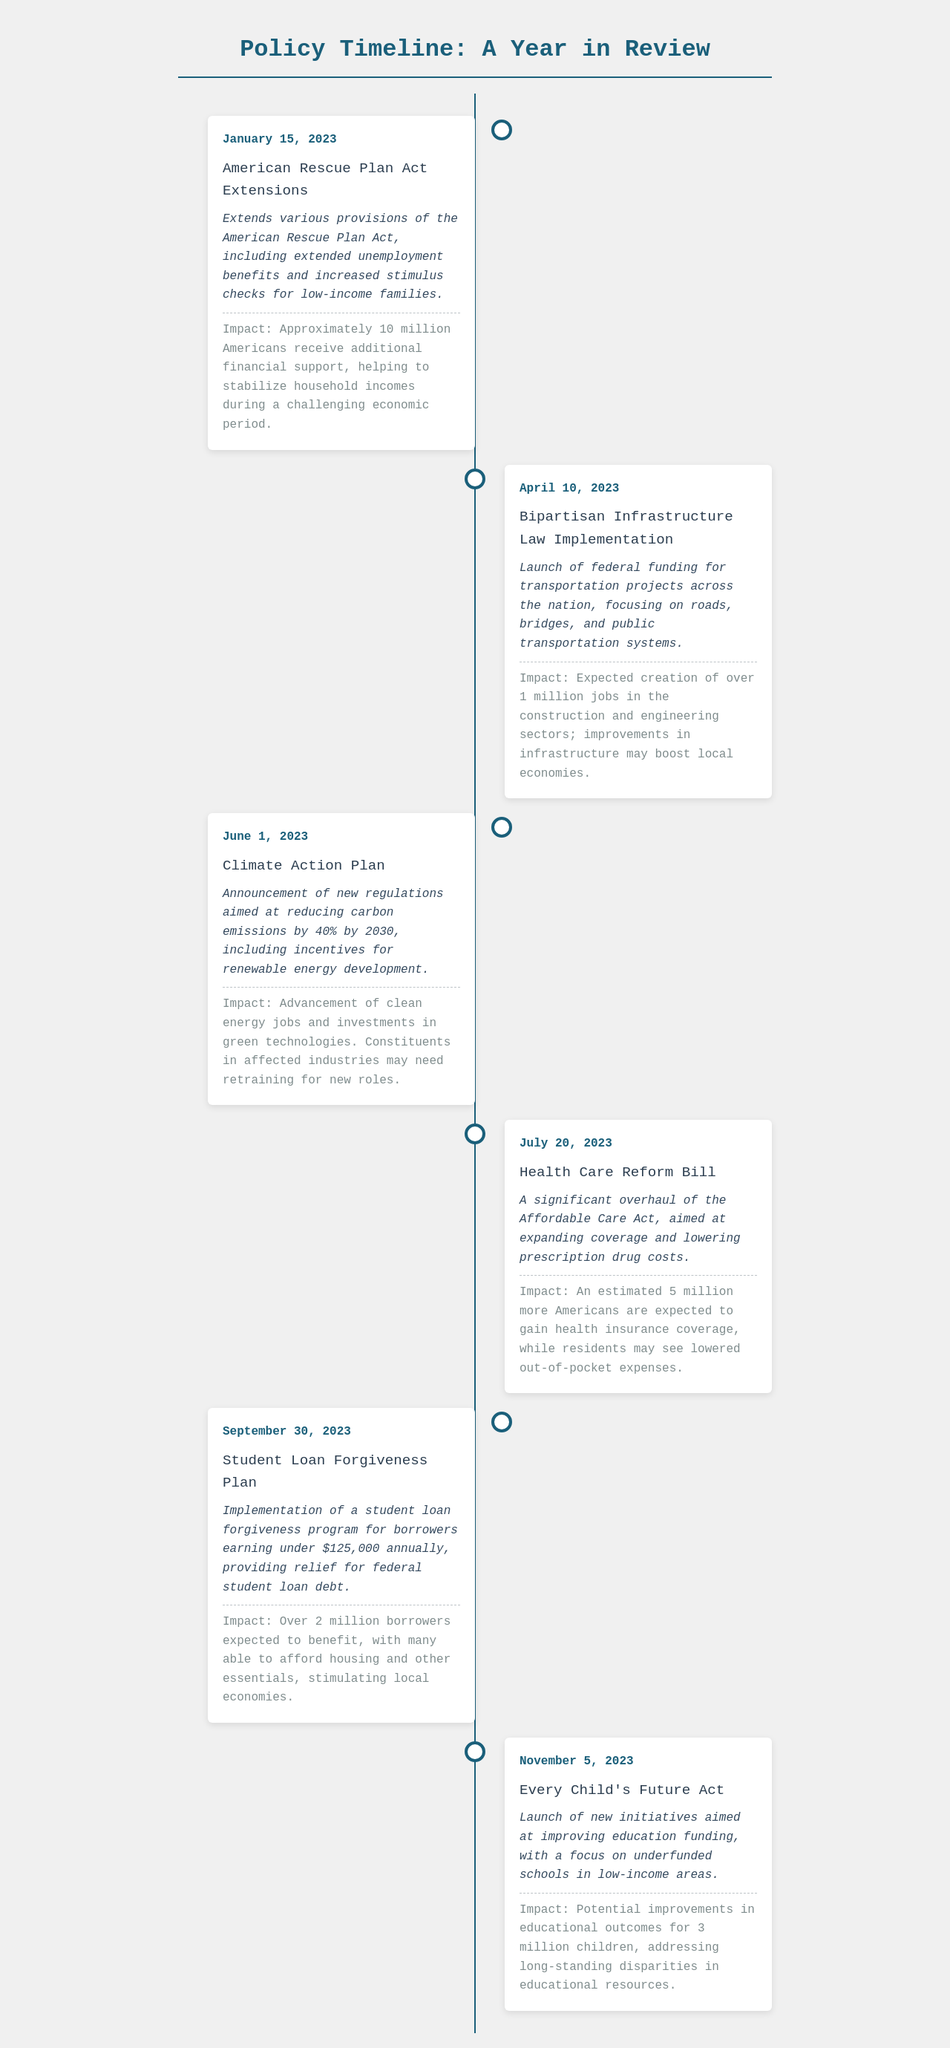What policy was announced on January 15, 2023? The document states that the policy announced on that date is an extension of various provisions of the American Rescue Plan Act.
Answer: American Rescue Plan Act Extensions How many Americans are estimated to benefit from the Health Care Reform Bill? The document mentions that approximately 5 million more Americans are expected to gain health insurance coverage due to this bill.
Answer: 5 million What is the main focus of the Every Child's Future Act? According to the document, the focus of this act is on improving education funding for underfunded schools in low-income areas.
Answer: Improving education funding What date was the Climate Action Plan announced? The document indicates that the Climate Action Plan was announced on June 1, 2023.
Answer: June 1, 2023 What is the expected impact of the Student Loan Forgiveness Plan? The document states that the expected impact is that over 2 million borrowers will benefit, allowing them to afford housing and essentials.
Answer: Over 2 million borrowers What significant change is included in the Bipartisan Infrastructure Law? The document highlights the launch of federal funding for transportation projects as a significant change included in this law.
Answer: Federal funding for transportation projects Which policy aims to reduce carbon emissions by 40%? The document specifies that the Climate Action Plan aims to reduce carbon emissions by 40% by 2030.
Answer: Climate Action Plan When is the implementation date for the Student Loan Forgiveness Plan? The document states the implementation date as September 30, 2023.
Answer: September 30, 2023 What is a potential outcome for children as a result of the Every Child's Future Act? The document mentions that a potential improvement in educational outcomes for 3 million children is an outcome of this act.
Answer: 3 million children 